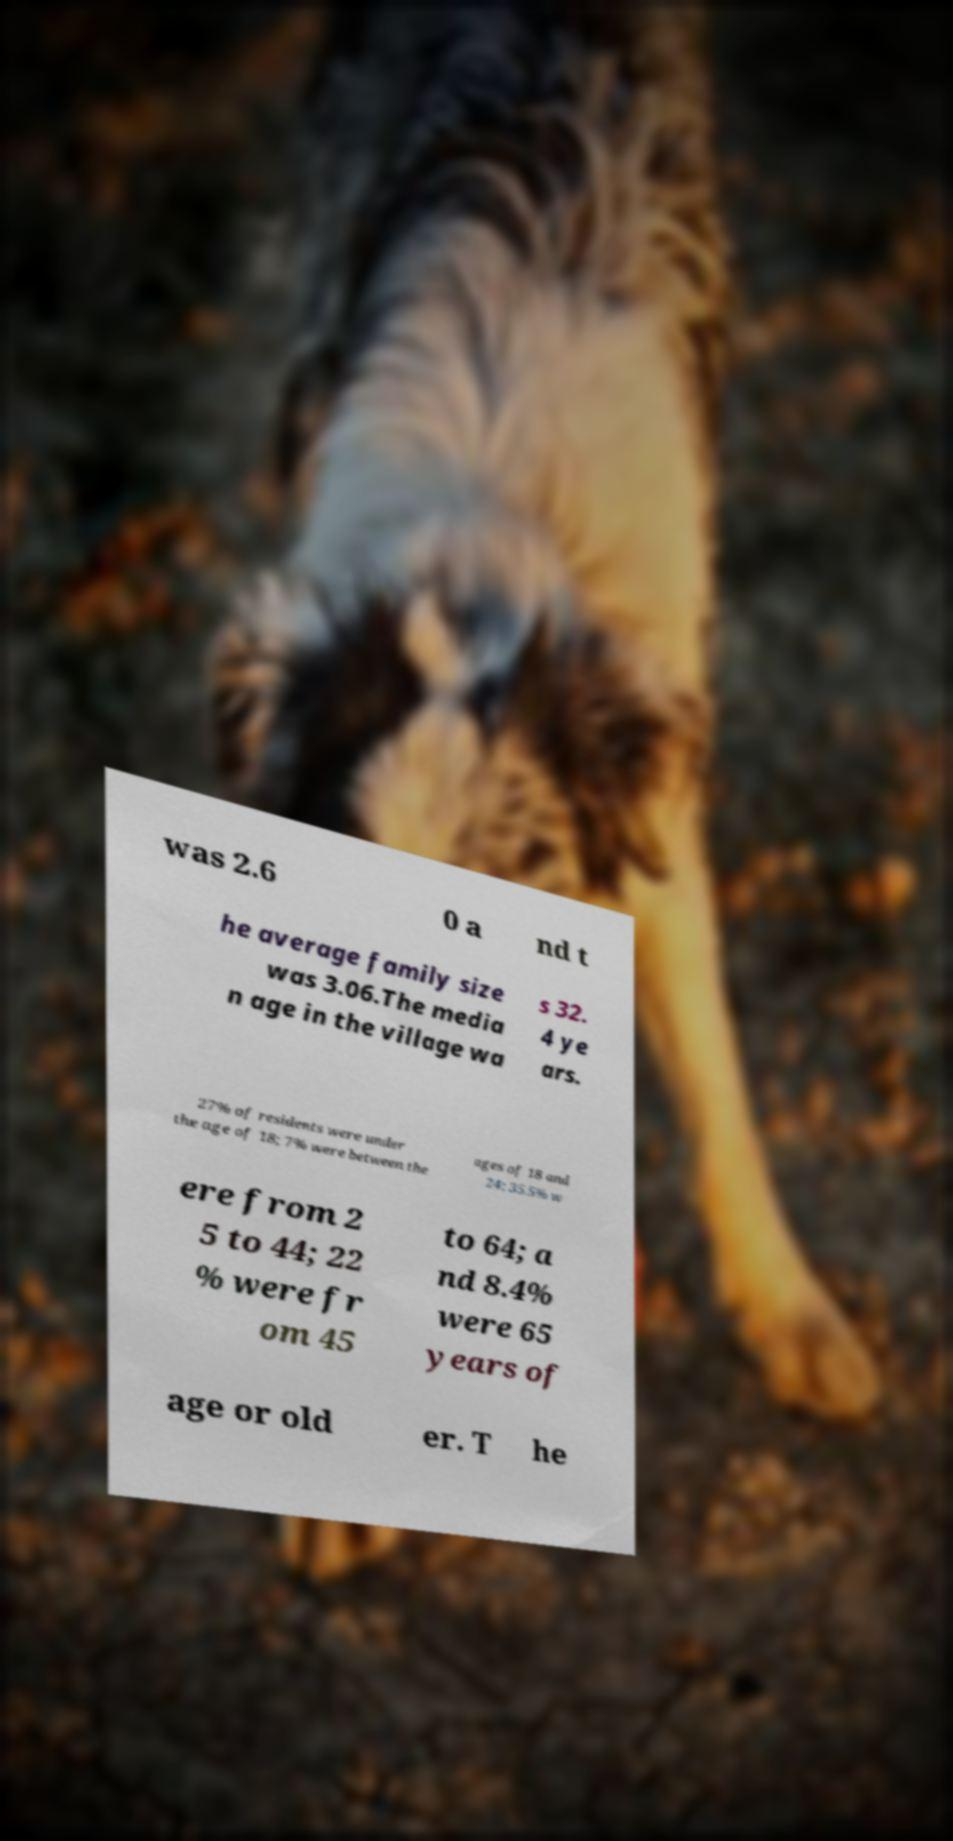For documentation purposes, I need the text within this image transcribed. Could you provide that? was 2.6 0 a nd t he average family size was 3.06.The media n age in the village wa s 32. 4 ye ars. 27% of residents were under the age of 18; 7% were between the ages of 18 and 24; 35.5% w ere from 2 5 to 44; 22 % were fr om 45 to 64; a nd 8.4% were 65 years of age or old er. T he 